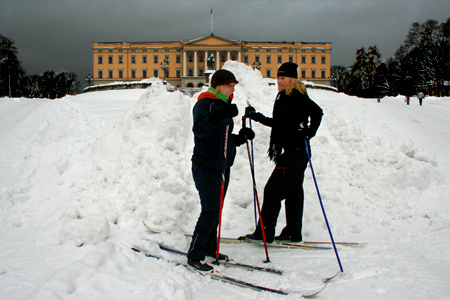Where do you think these individuals might go after their skiing adventure? After their skiing adventure, these individuals might head to a cozy cabin nearby to warm up by a fireplace, enjoy hot beverages, and share stories of their skiing experiences. They could also explore the local area, visiting a nearby café or delving into other winter sports activities. 